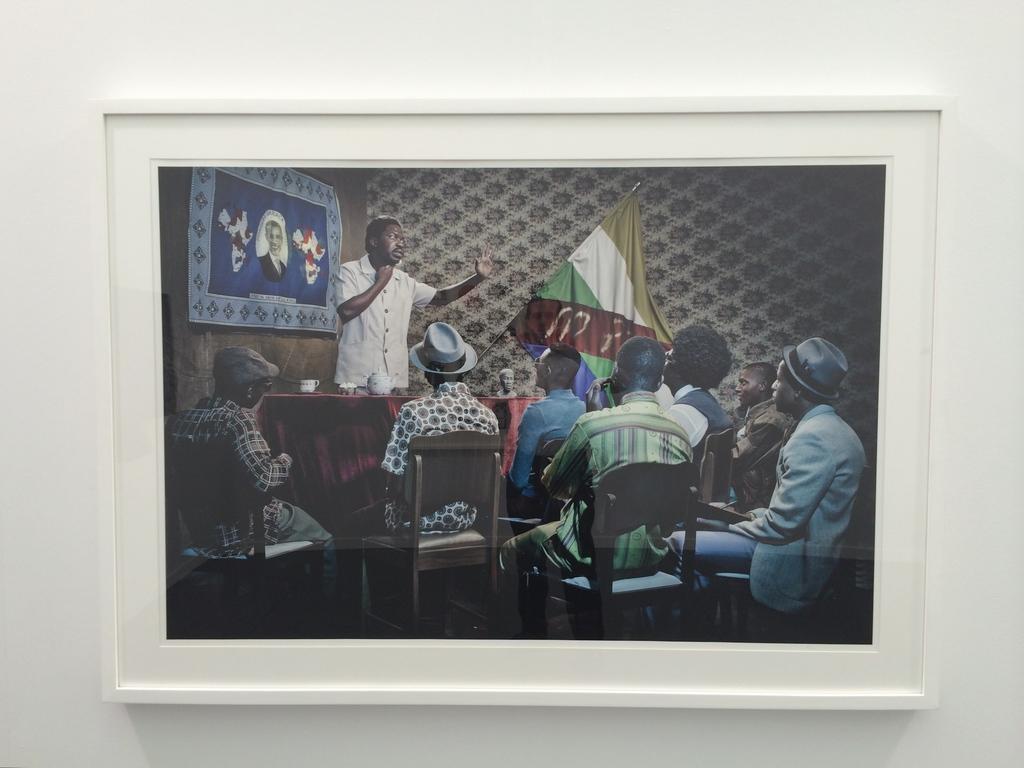Describe this image in one or two sentences. In the picture I can see the photo frame on the wall. In the photo frame I can see a few people sitting on the chairs and there is a man standing and looks like he is speaking. I can see a photo frame on the left side and there is a flagpole in the photo frame. 